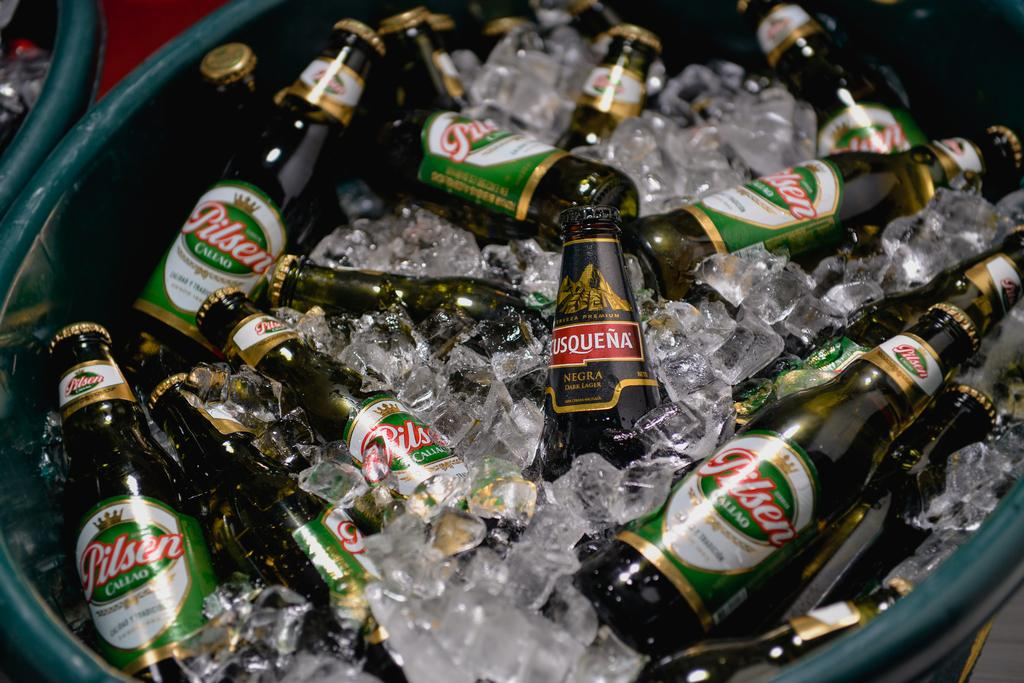<image>
Create a compact narrative representing the image presented. lots of bottle of beer the brand is pilsen in a tub of ice 